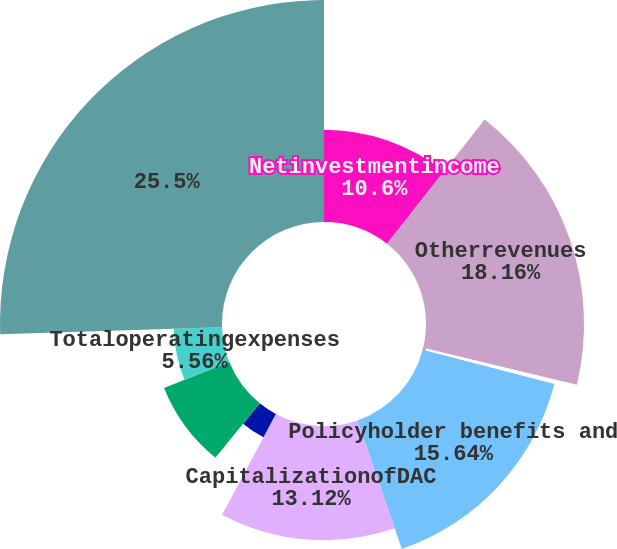<chart> <loc_0><loc_0><loc_500><loc_500><pie_chart><fcel>Netinvestmentincome<fcel>Otherrevenues<fcel>Totaloperatingrevenues<fcel>Policyholder benefits and<fcel>CapitalizationofDAC<fcel>AmortizationofDACandVOBA<fcel>Otherexpenses<fcel>Totaloperatingexpenses<fcel>Unnamed: 8<nl><fcel>10.6%<fcel>18.16%<fcel>0.3%<fcel>15.64%<fcel>13.12%<fcel>3.04%<fcel>8.08%<fcel>5.56%<fcel>25.51%<nl></chart> 